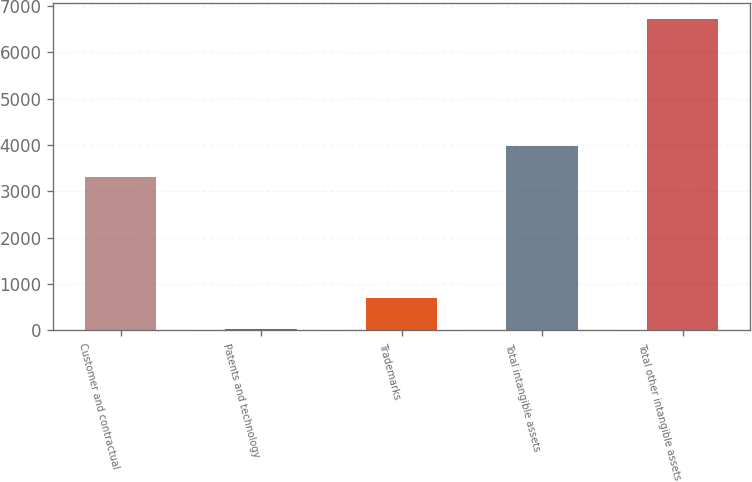Convert chart to OTSL. <chart><loc_0><loc_0><loc_500><loc_500><bar_chart><fcel>Customer and contractual<fcel>Patents and technology<fcel>Trademarks<fcel>Total intangible assets<fcel>Total other intangible assets<nl><fcel>3314.3<fcel>41.1<fcel>708.87<fcel>3982.07<fcel>6718.8<nl></chart> 